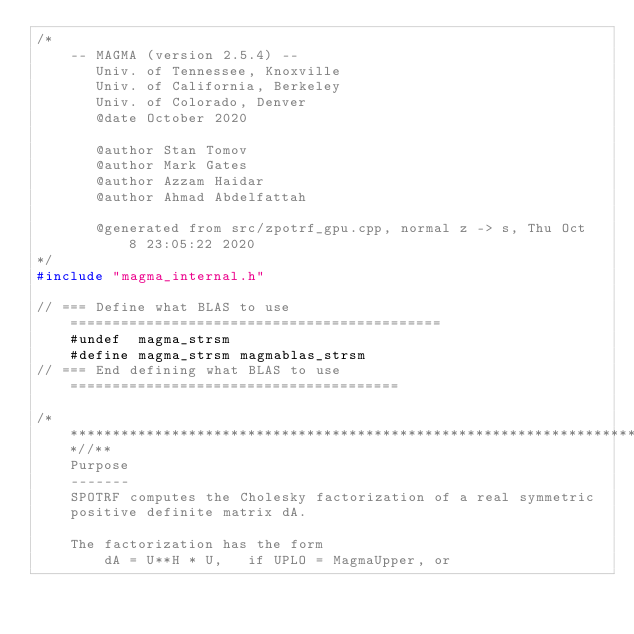<code> <loc_0><loc_0><loc_500><loc_500><_C++_>/*
    -- MAGMA (version 2.5.4) --
       Univ. of Tennessee, Knoxville
       Univ. of California, Berkeley
       Univ. of Colorado, Denver
       @date October 2020

       @author Stan Tomov
       @author Mark Gates
       @author Azzam Haidar
       @author Ahmad Abdelfattah
       
       @generated from src/zpotrf_gpu.cpp, normal z -> s, Thu Oct  8 23:05:22 2020
*/
#include "magma_internal.h"

// === Define what BLAS to use ============================================
    #undef  magma_strsm
    #define magma_strsm magmablas_strsm
// === End defining what BLAS to use =======================================

/***************************************************************************//**
    Purpose
    -------
    SPOTRF computes the Cholesky factorization of a real symmetric
    positive definite matrix dA.

    The factorization has the form
        dA = U**H * U,   if UPLO = MagmaUpper, or</code> 